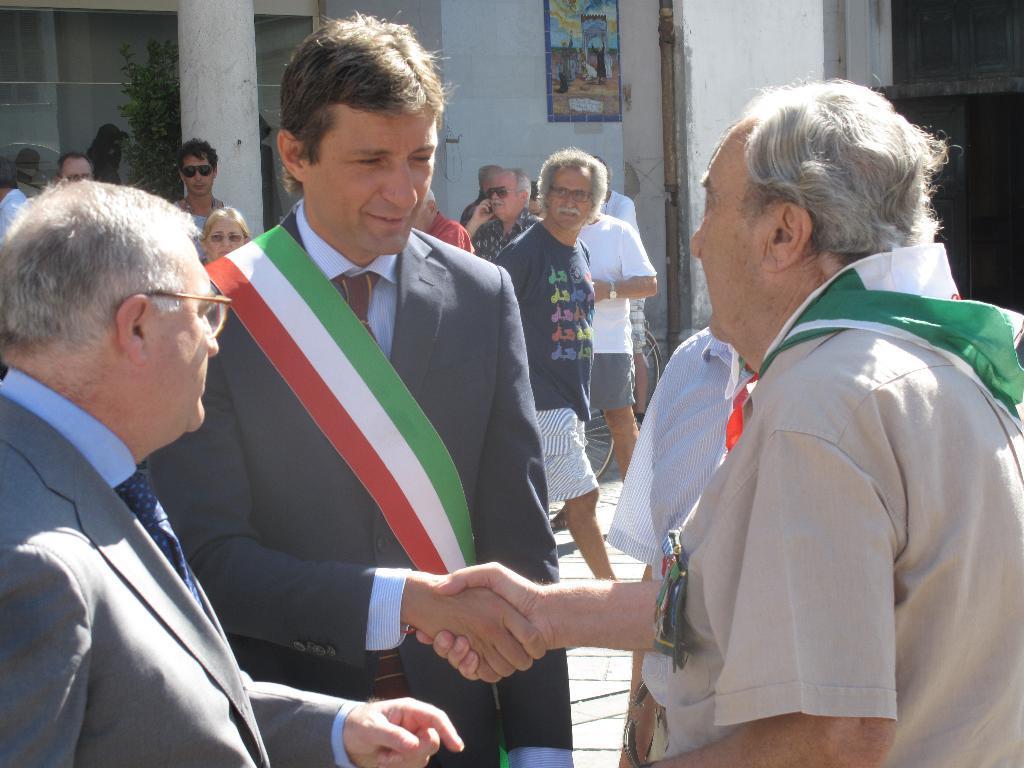Describe this image in one or two sentences. In this image there is a person wearing a blazer and tie. He is shaking the hand of a person. Left side there is a person wearing spectacles. There are people on the floor. Behind them there is a bicycle. Left side there is a pillar. Behind there is a plant. There is a poster attached to the wall. 